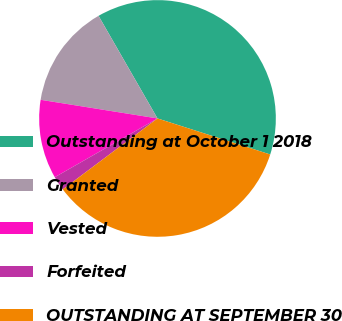Convert chart. <chart><loc_0><loc_0><loc_500><loc_500><pie_chart><fcel>Outstanding at October 1 2018<fcel>Granted<fcel>Vested<fcel>Forfeited<fcel>OUTSTANDING AT SEPTEMBER 30<nl><fcel>38.22%<fcel>14.18%<fcel>10.79%<fcel>1.96%<fcel>34.84%<nl></chart> 